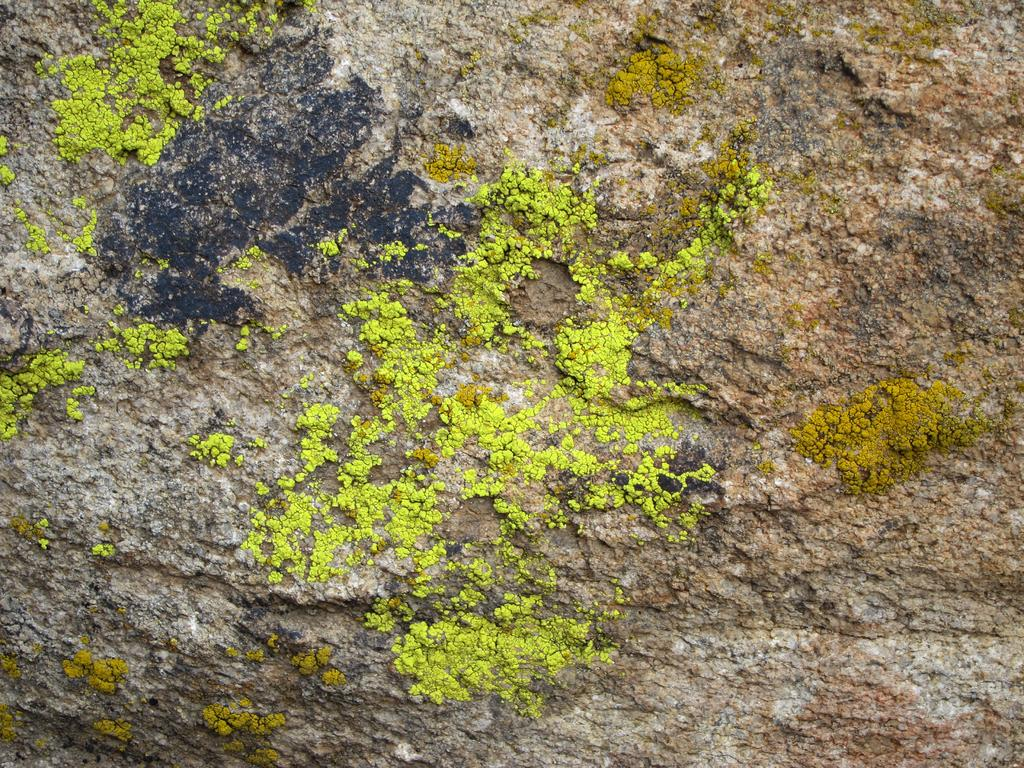What is the main object in the image? There is a stone in the image. Can you describe the colors of the stone? The stone has green and black colors on it. What type of crate is visible in the image? There is no crate present in the image. What is the purpose of the bomb in the image? There is no bomb present in the image. 